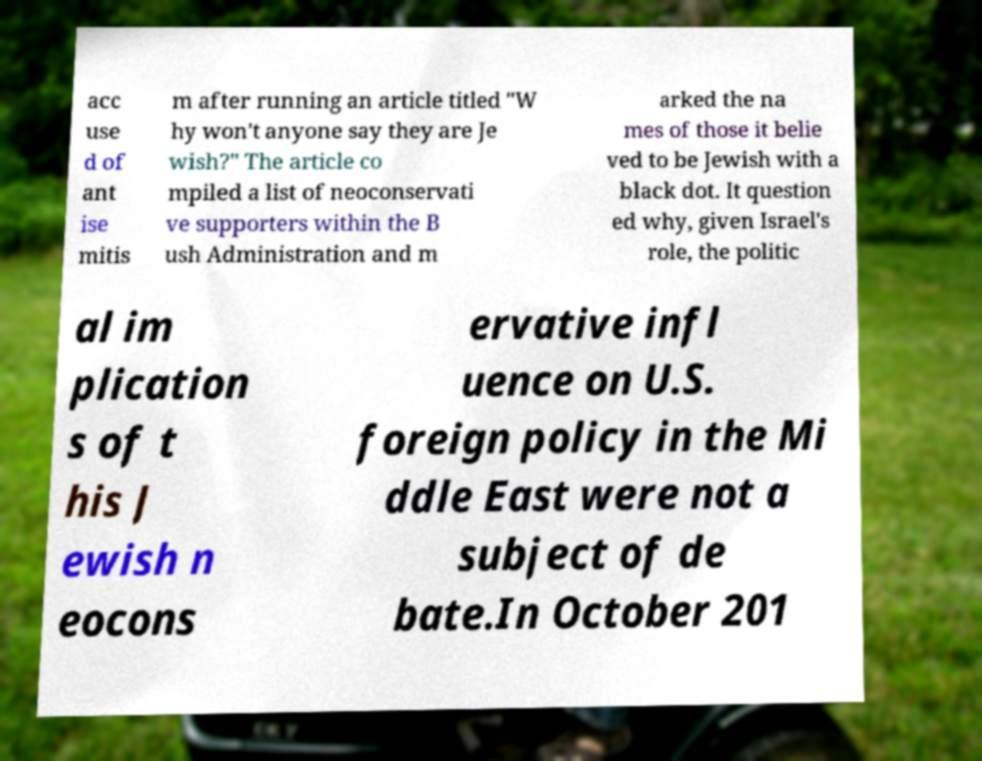There's text embedded in this image that I need extracted. Can you transcribe it verbatim? acc use d of ant ise mitis m after running an article titled "W hy won't anyone say they are Je wish?" The article co mpiled a list of neoconservati ve supporters within the B ush Administration and m arked the na mes of those it belie ved to be Jewish with a black dot. It question ed why, given Israel's role, the politic al im plication s of t his J ewish n eocons ervative infl uence on U.S. foreign policy in the Mi ddle East were not a subject of de bate.In October 201 